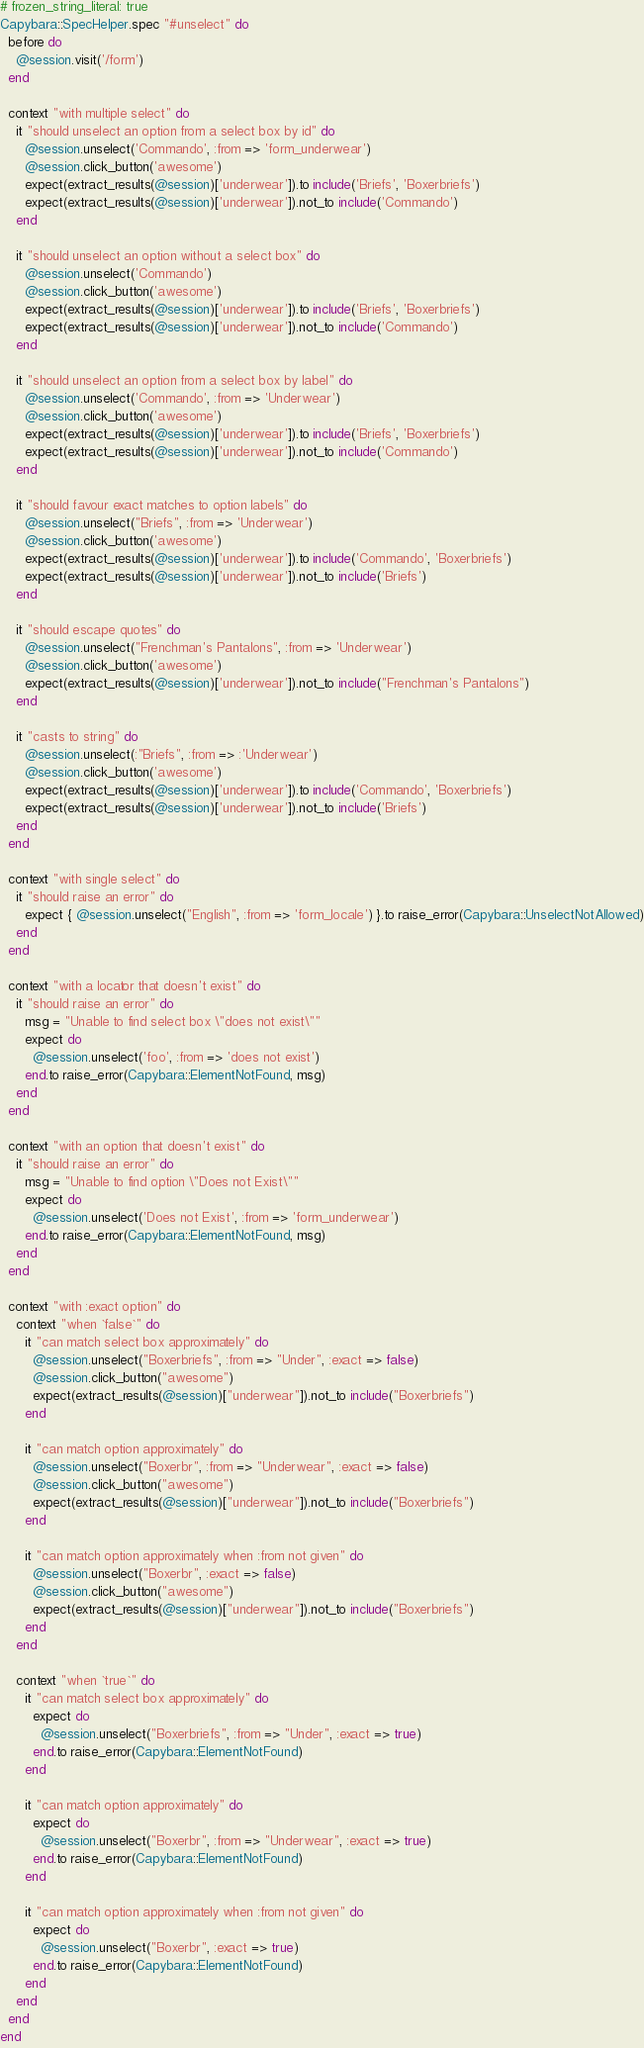Convert code to text. <code><loc_0><loc_0><loc_500><loc_500><_Ruby_># frozen_string_literal: true
Capybara::SpecHelper.spec "#unselect" do
  before do
    @session.visit('/form')
  end

  context "with multiple select" do
    it "should unselect an option from a select box by id" do
      @session.unselect('Commando', :from => 'form_underwear')
      @session.click_button('awesome')
      expect(extract_results(@session)['underwear']).to include('Briefs', 'Boxerbriefs')
      expect(extract_results(@session)['underwear']).not_to include('Commando')
    end

    it "should unselect an option without a select box" do
      @session.unselect('Commando')
      @session.click_button('awesome')
      expect(extract_results(@session)['underwear']).to include('Briefs', 'Boxerbriefs')
      expect(extract_results(@session)['underwear']).not_to include('Commando')
    end

    it "should unselect an option from a select box by label" do
      @session.unselect('Commando', :from => 'Underwear')
      @session.click_button('awesome')
      expect(extract_results(@session)['underwear']).to include('Briefs', 'Boxerbriefs')
      expect(extract_results(@session)['underwear']).not_to include('Commando')
    end

    it "should favour exact matches to option labels" do
      @session.unselect("Briefs", :from => 'Underwear')
      @session.click_button('awesome')
      expect(extract_results(@session)['underwear']).to include('Commando', 'Boxerbriefs')
      expect(extract_results(@session)['underwear']).not_to include('Briefs')
    end

    it "should escape quotes" do
      @session.unselect("Frenchman's Pantalons", :from => 'Underwear')
      @session.click_button('awesome')
      expect(extract_results(@session)['underwear']).not_to include("Frenchman's Pantalons")
    end

    it "casts to string" do
      @session.unselect(:"Briefs", :from => :'Underwear')
      @session.click_button('awesome')
      expect(extract_results(@session)['underwear']).to include('Commando', 'Boxerbriefs')
      expect(extract_results(@session)['underwear']).not_to include('Briefs')
    end
  end

  context "with single select" do
    it "should raise an error" do
      expect { @session.unselect("English", :from => 'form_locale') }.to raise_error(Capybara::UnselectNotAllowed)
    end
  end

  context "with a locator that doesn't exist" do
    it "should raise an error" do
      msg = "Unable to find select box \"does not exist\""
      expect do
        @session.unselect('foo', :from => 'does not exist')
      end.to raise_error(Capybara::ElementNotFound, msg)
    end
  end

  context "with an option that doesn't exist" do
    it "should raise an error" do
      msg = "Unable to find option \"Does not Exist\""
      expect do
        @session.unselect('Does not Exist', :from => 'form_underwear')
      end.to raise_error(Capybara::ElementNotFound, msg)
    end
  end

  context "with :exact option" do
    context "when `false`" do
      it "can match select box approximately" do
        @session.unselect("Boxerbriefs", :from => "Under", :exact => false)
        @session.click_button("awesome")
        expect(extract_results(@session)["underwear"]).not_to include("Boxerbriefs")
      end

      it "can match option approximately" do
        @session.unselect("Boxerbr", :from => "Underwear", :exact => false)
        @session.click_button("awesome")
        expect(extract_results(@session)["underwear"]).not_to include("Boxerbriefs")
      end

      it "can match option approximately when :from not given" do
        @session.unselect("Boxerbr", :exact => false)
        @session.click_button("awesome")
        expect(extract_results(@session)["underwear"]).not_to include("Boxerbriefs")
      end
    end

    context "when `true`" do
      it "can match select box approximately" do
        expect do
          @session.unselect("Boxerbriefs", :from => "Under", :exact => true)
        end.to raise_error(Capybara::ElementNotFound)
      end

      it "can match option approximately" do
        expect do
          @session.unselect("Boxerbr", :from => "Underwear", :exact => true)
        end.to raise_error(Capybara::ElementNotFound)
      end

      it "can match option approximately when :from not given" do
        expect do
          @session.unselect("Boxerbr", :exact => true)
        end.to raise_error(Capybara::ElementNotFound)
      end
    end
  end
end
</code> 